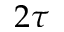Convert formula to latex. <formula><loc_0><loc_0><loc_500><loc_500>2 \tau</formula> 